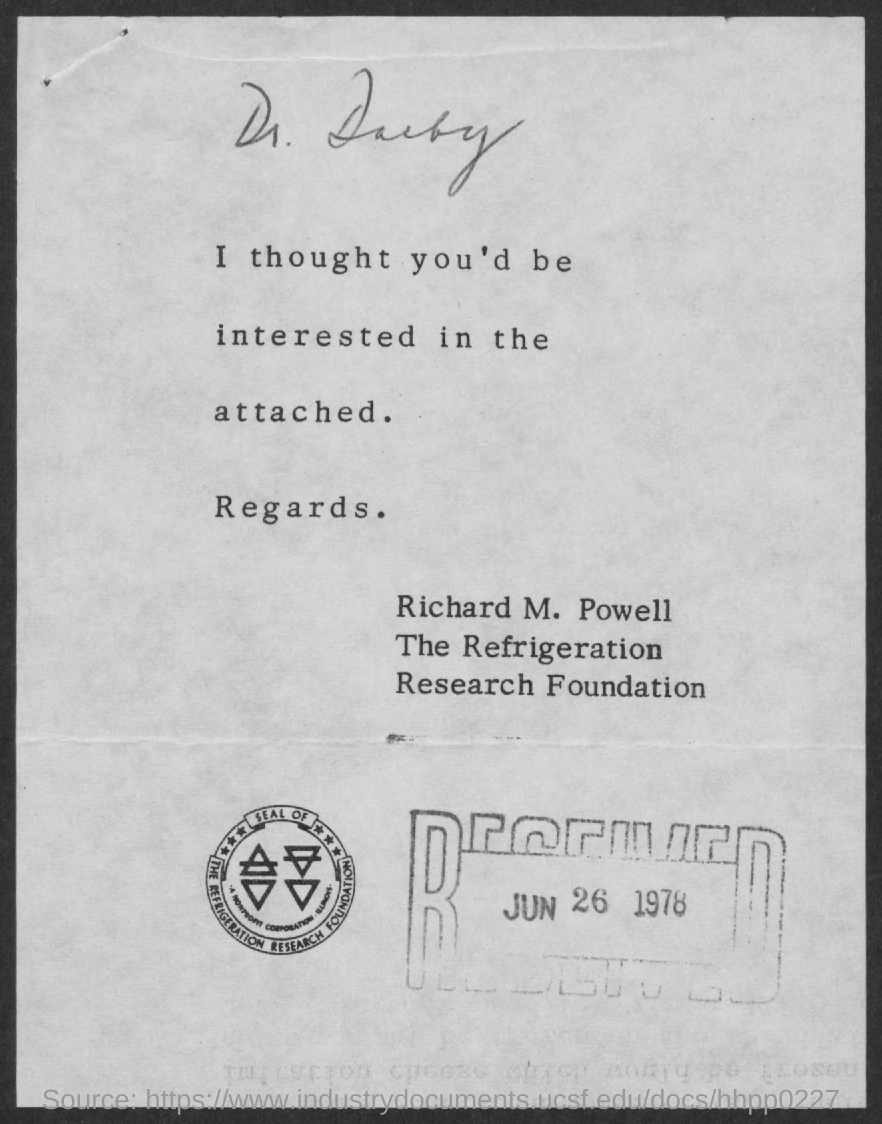List a handful of essential elements in this visual. The letter is addressed to Dr. Darby. The received date of this letter is June 26, 1978. The sender of this letter is Richard M. Powell. The referenced company seal is shown here: THE REFRIGERATION RESEARCH FOUNDATION. 